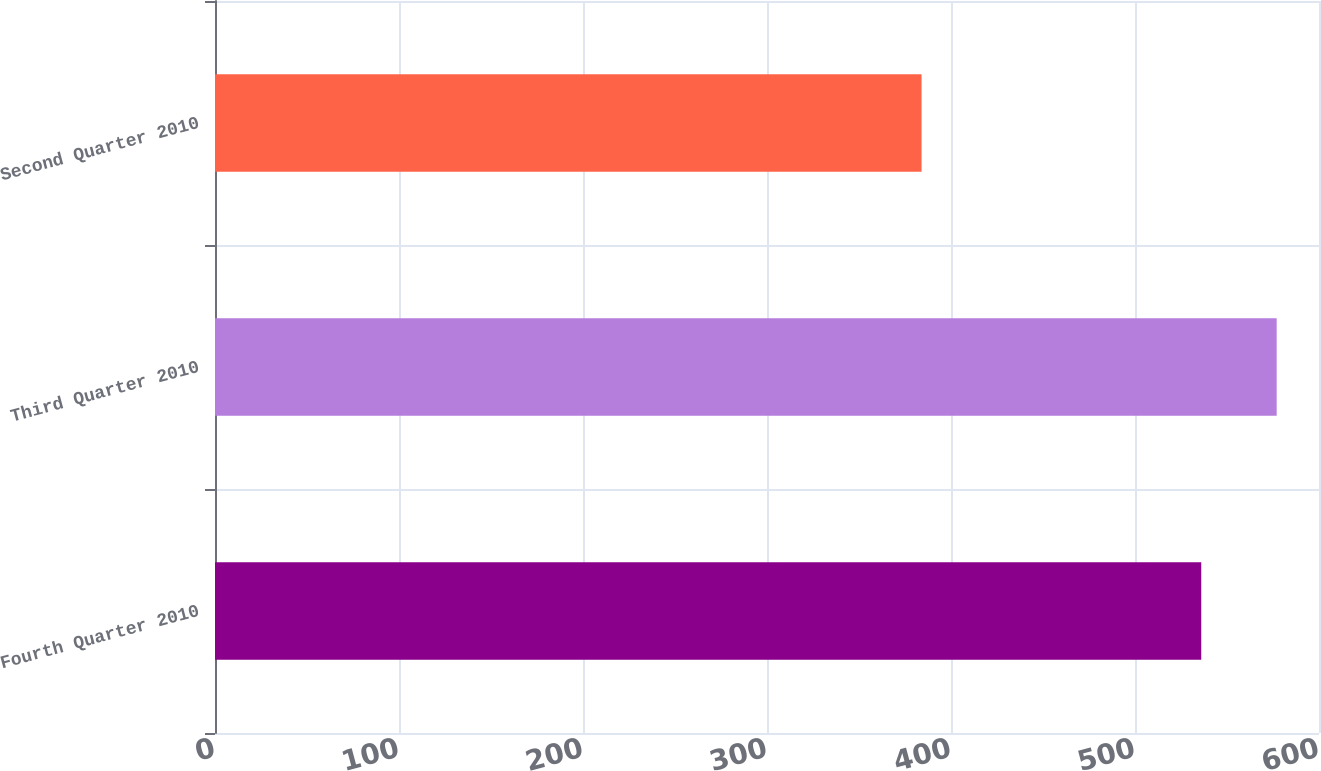Convert chart to OTSL. <chart><loc_0><loc_0><loc_500><loc_500><bar_chart><fcel>Fourth Quarter 2010<fcel>Third Quarter 2010<fcel>Second Quarter 2010<nl><fcel>536<fcel>577<fcel>384<nl></chart> 